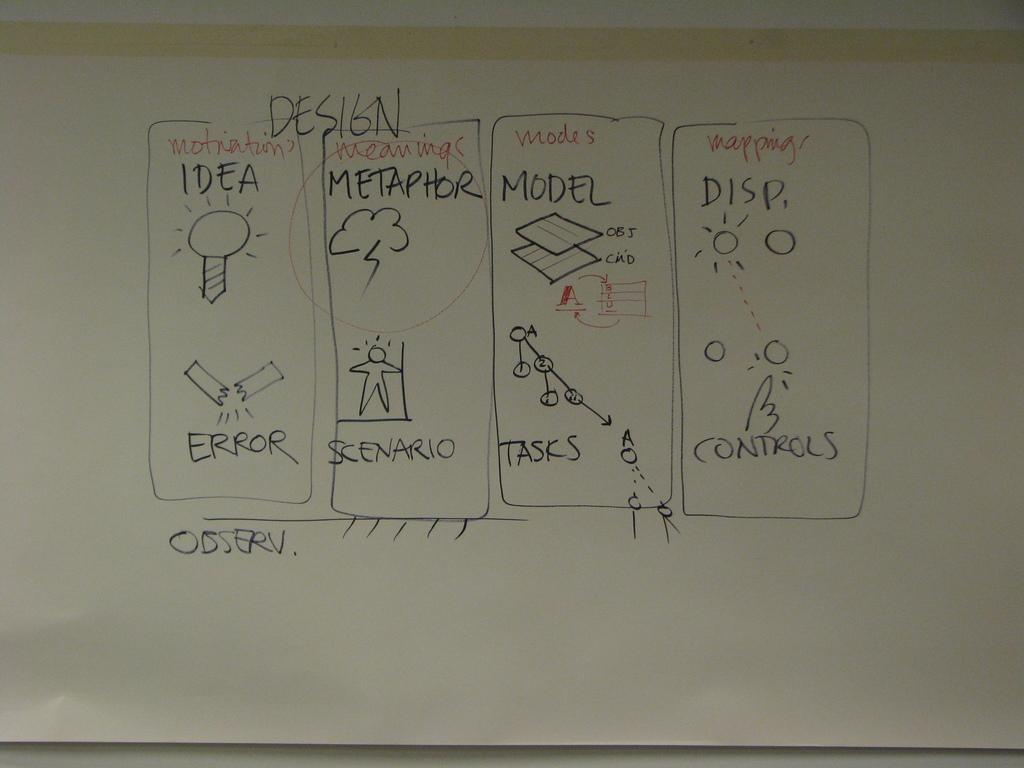What is under modes?
Your response must be concise. Model. How many steps are present?
Ensure brevity in your answer.  4. 